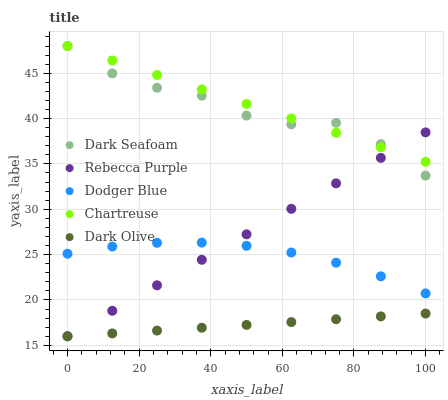Does Dark Olive have the minimum area under the curve?
Answer yes or no. Yes. Does Chartreuse have the maximum area under the curve?
Answer yes or no. Yes. Does Dodger Blue have the minimum area under the curve?
Answer yes or no. No. Does Dodger Blue have the maximum area under the curve?
Answer yes or no. No. Is Chartreuse the smoothest?
Answer yes or no. Yes. Is Dark Seafoam the roughest?
Answer yes or no. Yes. Is Dark Olive the smoothest?
Answer yes or no. No. Is Dark Olive the roughest?
Answer yes or no. No. Does Dark Olive have the lowest value?
Answer yes or no. Yes. Does Dodger Blue have the lowest value?
Answer yes or no. No. Does Chartreuse have the highest value?
Answer yes or no. Yes. Does Dodger Blue have the highest value?
Answer yes or no. No. Is Dark Olive less than Dark Seafoam?
Answer yes or no. Yes. Is Chartreuse greater than Dark Olive?
Answer yes or no. Yes. Does Dodger Blue intersect Rebecca Purple?
Answer yes or no. Yes. Is Dodger Blue less than Rebecca Purple?
Answer yes or no. No. Is Dodger Blue greater than Rebecca Purple?
Answer yes or no. No. Does Dark Olive intersect Dark Seafoam?
Answer yes or no. No. 